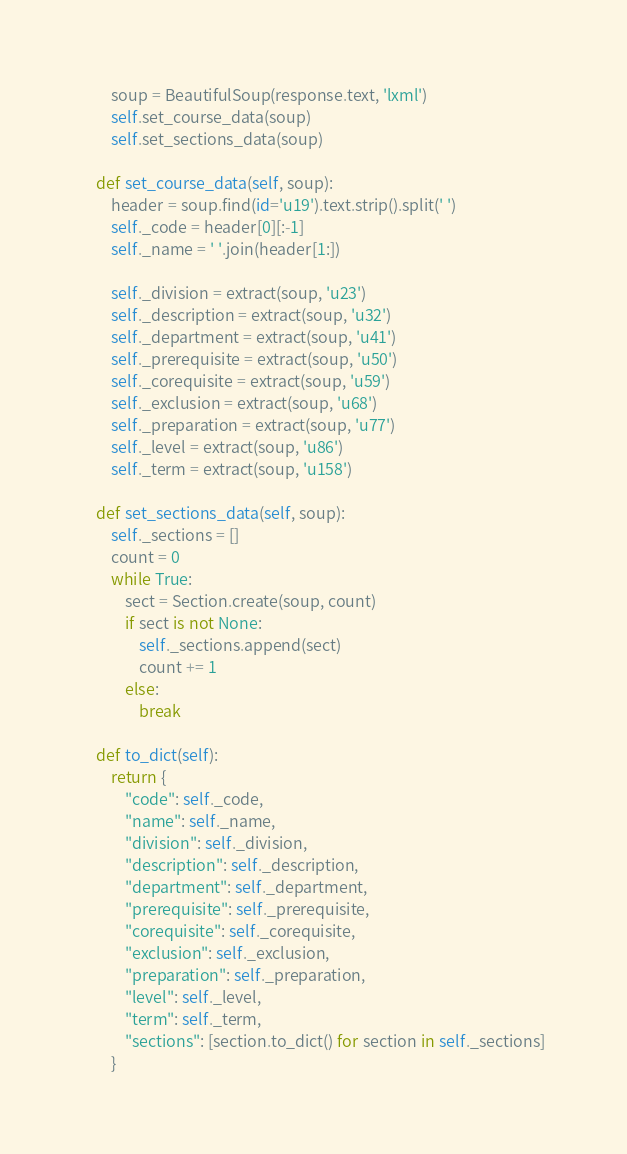<code> <loc_0><loc_0><loc_500><loc_500><_Python_>        soup = BeautifulSoup(response.text, 'lxml')
        self.set_course_data(soup)
        self.set_sections_data(soup)

    def set_course_data(self, soup):
        header = soup.find(id='u19').text.strip().split(' ')
        self._code = header[0][:-1]
        self._name = ' '.join(header[1:])

        self._division = extract(soup, 'u23')
        self._description = extract(soup, 'u32')
        self._department = extract(soup, 'u41')
        self._prerequisite = extract(soup, 'u50')
        self._corequisite = extract(soup, 'u59')
        self._exclusion = extract(soup, 'u68')
        self._preparation = extract(soup, 'u77')
        self._level = extract(soup, 'u86')
        self._term = extract(soup, 'u158')

    def set_sections_data(self, soup):
        self._sections = []
        count = 0
        while True:
            sect = Section.create(soup, count)
            if sect is not None:
                self._sections.append(sect)
                count += 1
            else:
                break

    def to_dict(self):
        return {
            "code": self._code,
            "name": self._name,
            "division": self._division,
            "description": self._description,
            "department": self._department,
            "prerequisite": self._prerequisite,
            "corequisite": self._corequisite,
            "exclusion": self._exclusion,
            "preparation": self._preparation,
            "level": self._level,
            "term": self._term,
            "sections": [section.to_dict() for section in self._sections]
        }
</code> 